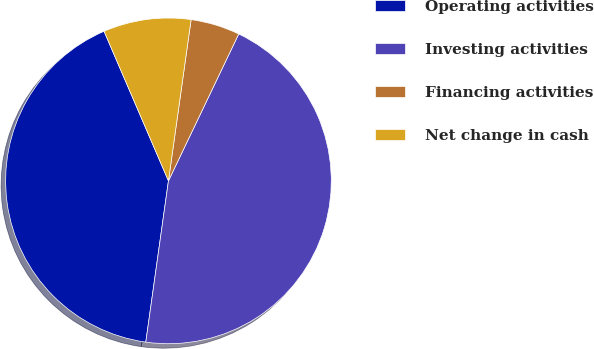Convert chart. <chart><loc_0><loc_0><loc_500><loc_500><pie_chart><fcel>Operating activities<fcel>Investing activities<fcel>Financing activities<fcel>Net change in cash<nl><fcel>41.31%<fcel>45.12%<fcel>4.88%<fcel>8.69%<nl></chart> 